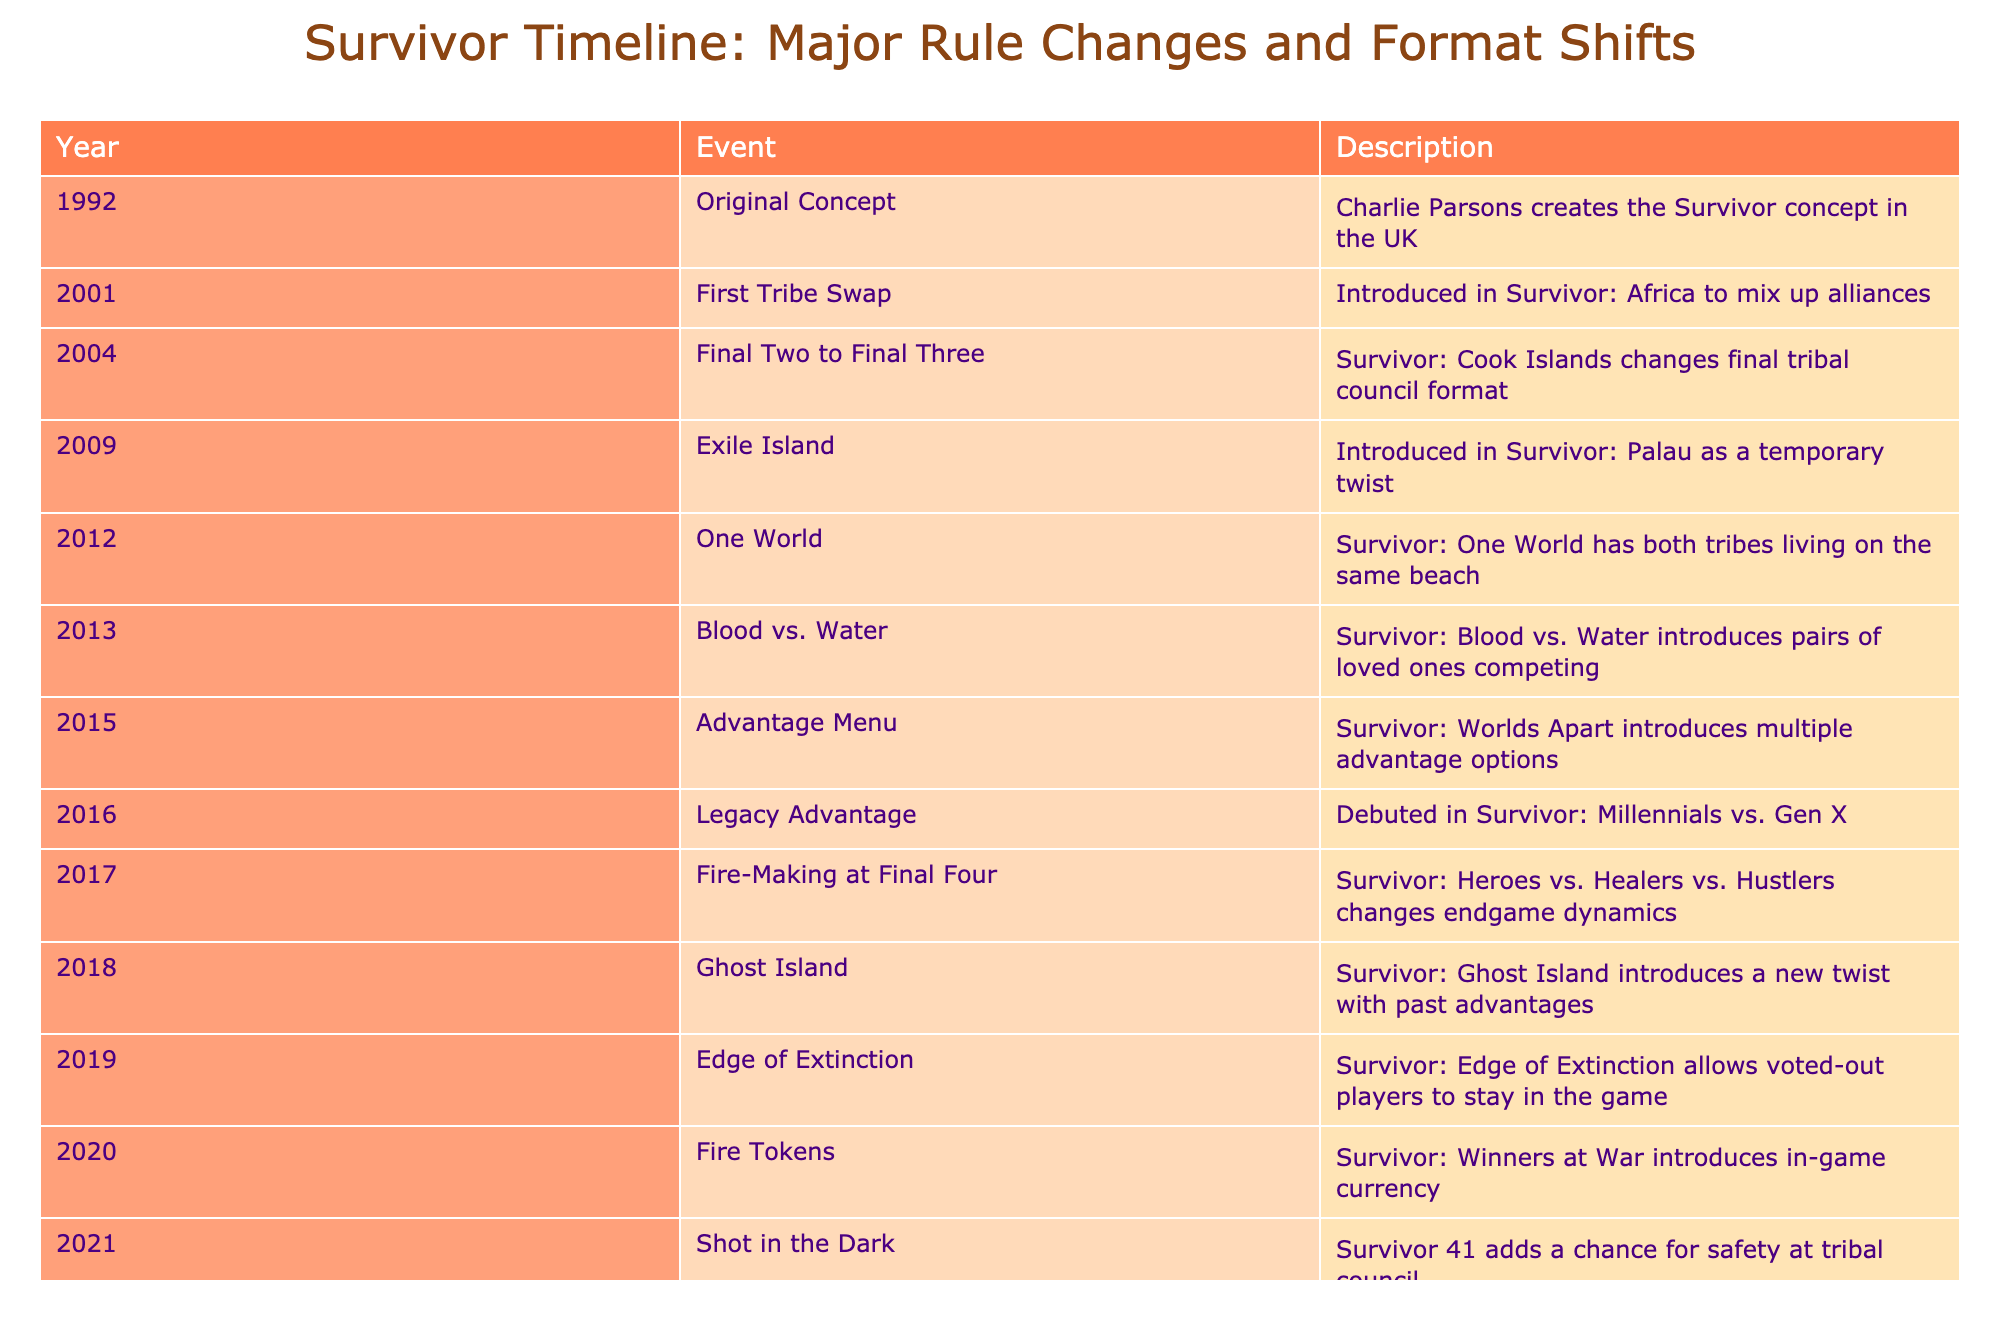What year was the Original Concept of Survivor created? The table indicates that the Original Concept was created in the UK in 1992.
Answer: 1992 Which season introduced the Fire-Making at Final Four rule? According to the table, the Fire-Making at Final Four rule was introduced in the year 2017, specifically in Survivor: Heroes vs. Healers vs. Hustlers.
Answer: 2017 What is the significance of the year 2013 in Survivor's history? In 2013, Survivor: Blood vs. Water introduced the unique concept of pairs of loved ones competing against each other.
Answer: Blood vs. Water How many major rule changes occurred between 2010 and 2020? Reviewing the years, there are five significant events: 2012 (One World), 2013 (Blood vs. Water), 2015 (Advantage Menu), 2016 (Legacy Advantage), and 2020 (Fire Tokens). The total is 5 changes.
Answer: 5 Was the Edge of Extinction rule present before or after the introduction of Fire Tokens? The table shows that Fire Tokens were introduced in 2020 and Edge of Extinction was introduced in 2019. Thus, Edge of Extinction was introduced before Fire Tokens.
Answer: Before In which season did the final council format change from Final Two to Final Three? The season that changed the final council format to Final Three was Survivor: Cook Islands, which occurred in 2004.
Answer: Cook Islands How many different major rule changes were introduced from 2000 to 2019? Counting the years from 2000 to 2019 in the table, the rule changes were in 2001 (First Tribe Swap), 2004 (Final Two to Final Three), 2009 (Exile Island), 2012 (One World), 2013 (Blood vs. Water), 2015 (Advantage Menu), 2016 (Legacy Advantage), 2017 (Fire-Making at Final Four), 2018 (Ghost Island), and 2019 (Edge of Extinction), resulting in 9 changes in total.
Answer: 9 What twist did Survivor: One World introduce in 2012? Survivor: One World introduced the twist of having both tribes live on the same beach, as stated in the table.
Answer: Both tribes on the same beach Which season marks the debut of the Legacy Advantage rule? The Legacy Advantage rule debuted in the 2016 season, Survivor: Millennials vs. Gen X, according to the table.
Answer: Millennials vs. Gen X 